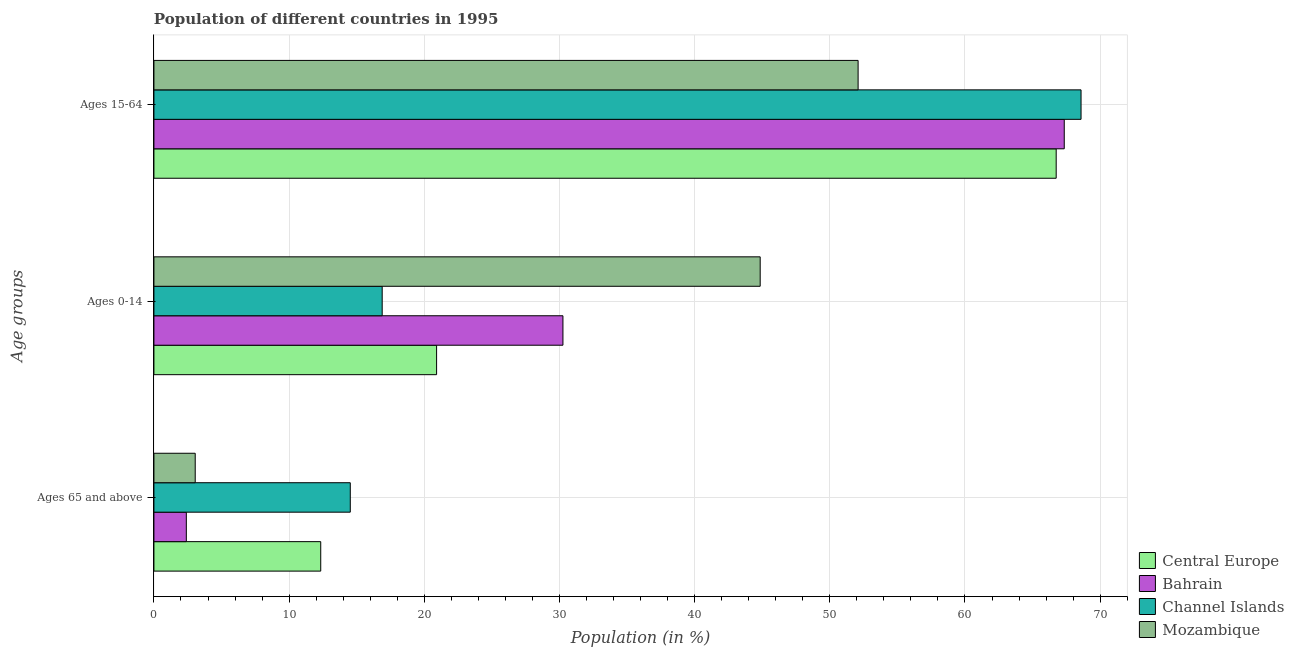How many different coloured bars are there?
Ensure brevity in your answer.  4. How many groups of bars are there?
Ensure brevity in your answer.  3. Are the number of bars per tick equal to the number of legend labels?
Your answer should be very brief. Yes. How many bars are there on the 2nd tick from the bottom?
Ensure brevity in your answer.  4. What is the label of the 1st group of bars from the top?
Give a very brief answer. Ages 15-64. What is the percentage of population within the age-group 0-14 in Channel Islands?
Your answer should be compact. 16.89. Across all countries, what is the maximum percentage of population within the age-group 0-14?
Ensure brevity in your answer.  44.85. Across all countries, what is the minimum percentage of population within the age-group 0-14?
Offer a very short reply. 16.89. In which country was the percentage of population within the age-group of 65 and above maximum?
Give a very brief answer. Channel Islands. In which country was the percentage of population within the age-group 15-64 minimum?
Your answer should be compact. Mozambique. What is the total percentage of population within the age-group 0-14 in the graph?
Make the answer very short. 112.91. What is the difference between the percentage of population within the age-group 15-64 in Channel Islands and that in Central Europe?
Offer a terse response. 1.84. What is the difference between the percentage of population within the age-group of 65 and above in Mozambique and the percentage of population within the age-group 0-14 in Bahrain?
Your answer should be compact. -27.2. What is the average percentage of population within the age-group 15-64 per country?
Keep it short and to the point. 63.69. What is the difference between the percentage of population within the age-group of 65 and above and percentage of population within the age-group 15-64 in Central Europe?
Your answer should be very brief. -54.41. What is the ratio of the percentage of population within the age-group of 65 and above in Mozambique to that in Channel Islands?
Offer a terse response. 0.21. Is the difference between the percentage of population within the age-group 0-14 in Central Europe and Mozambique greater than the difference between the percentage of population within the age-group 15-64 in Central Europe and Mozambique?
Your answer should be compact. No. What is the difference between the highest and the second highest percentage of population within the age-group of 65 and above?
Ensure brevity in your answer.  2.19. What is the difference between the highest and the lowest percentage of population within the age-group 15-64?
Keep it short and to the point. 16.49. What does the 2nd bar from the top in Ages 65 and above represents?
Your response must be concise. Channel Islands. What does the 3rd bar from the bottom in Ages 15-64 represents?
Offer a terse response. Channel Islands. How many bars are there?
Provide a succinct answer. 12. How many countries are there in the graph?
Offer a very short reply. 4. What is the difference between two consecutive major ticks on the X-axis?
Your answer should be very brief. 10. Does the graph contain any zero values?
Your answer should be compact. No. Does the graph contain grids?
Provide a succinct answer. Yes. Where does the legend appear in the graph?
Offer a terse response. Bottom right. What is the title of the graph?
Your answer should be very brief. Population of different countries in 1995. What is the label or title of the Y-axis?
Provide a short and direct response. Age groups. What is the Population (in %) of Central Europe in Ages 65 and above?
Offer a very short reply. 12.34. What is the Population (in %) in Bahrain in Ages 65 and above?
Keep it short and to the point. 2.4. What is the Population (in %) in Channel Islands in Ages 65 and above?
Keep it short and to the point. 14.53. What is the Population (in %) in Mozambique in Ages 65 and above?
Provide a succinct answer. 3.05. What is the Population (in %) of Central Europe in Ages 0-14?
Offer a terse response. 20.91. What is the Population (in %) of Bahrain in Ages 0-14?
Make the answer very short. 30.26. What is the Population (in %) in Channel Islands in Ages 0-14?
Give a very brief answer. 16.89. What is the Population (in %) in Mozambique in Ages 0-14?
Offer a terse response. 44.85. What is the Population (in %) of Central Europe in Ages 15-64?
Provide a short and direct response. 66.75. What is the Population (in %) in Bahrain in Ages 15-64?
Your answer should be compact. 67.35. What is the Population (in %) in Channel Islands in Ages 15-64?
Your response must be concise. 68.59. What is the Population (in %) in Mozambique in Ages 15-64?
Provide a short and direct response. 52.09. Across all Age groups, what is the maximum Population (in %) of Central Europe?
Ensure brevity in your answer.  66.75. Across all Age groups, what is the maximum Population (in %) in Bahrain?
Provide a short and direct response. 67.35. Across all Age groups, what is the maximum Population (in %) of Channel Islands?
Ensure brevity in your answer.  68.59. Across all Age groups, what is the maximum Population (in %) of Mozambique?
Your answer should be very brief. 52.09. Across all Age groups, what is the minimum Population (in %) of Central Europe?
Give a very brief answer. 12.34. Across all Age groups, what is the minimum Population (in %) of Bahrain?
Your response must be concise. 2.4. Across all Age groups, what is the minimum Population (in %) in Channel Islands?
Offer a very short reply. 14.53. Across all Age groups, what is the minimum Population (in %) of Mozambique?
Provide a succinct answer. 3.05. What is the total Population (in %) in Channel Islands in the graph?
Offer a very short reply. 100. What is the total Population (in %) of Mozambique in the graph?
Provide a short and direct response. 100. What is the difference between the Population (in %) of Central Europe in Ages 65 and above and that in Ages 0-14?
Your response must be concise. -8.57. What is the difference between the Population (in %) of Bahrain in Ages 65 and above and that in Ages 0-14?
Make the answer very short. -27.86. What is the difference between the Population (in %) of Channel Islands in Ages 65 and above and that in Ages 0-14?
Give a very brief answer. -2.36. What is the difference between the Population (in %) of Mozambique in Ages 65 and above and that in Ages 0-14?
Your answer should be compact. -41.8. What is the difference between the Population (in %) of Central Europe in Ages 65 and above and that in Ages 15-64?
Provide a succinct answer. -54.41. What is the difference between the Population (in %) of Bahrain in Ages 65 and above and that in Ages 15-64?
Give a very brief answer. -64.95. What is the difference between the Population (in %) in Channel Islands in Ages 65 and above and that in Ages 15-64?
Offer a terse response. -54.06. What is the difference between the Population (in %) in Mozambique in Ages 65 and above and that in Ages 15-64?
Make the answer very short. -49.04. What is the difference between the Population (in %) of Central Europe in Ages 0-14 and that in Ages 15-64?
Provide a succinct answer. -45.84. What is the difference between the Population (in %) in Bahrain in Ages 0-14 and that in Ages 15-64?
Make the answer very short. -37.09. What is the difference between the Population (in %) of Channel Islands in Ages 0-14 and that in Ages 15-64?
Provide a short and direct response. -51.7. What is the difference between the Population (in %) of Mozambique in Ages 0-14 and that in Ages 15-64?
Your answer should be very brief. -7.24. What is the difference between the Population (in %) in Central Europe in Ages 65 and above and the Population (in %) in Bahrain in Ages 0-14?
Ensure brevity in your answer.  -17.92. What is the difference between the Population (in %) of Central Europe in Ages 65 and above and the Population (in %) of Channel Islands in Ages 0-14?
Offer a terse response. -4.55. What is the difference between the Population (in %) in Central Europe in Ages 65 and above and the Population (in %) in Mozambique in Ages 0-14?
Your response must be concise. -32.51. What is the difference between the Population (in %) of Bahrain in Ages 65 and above and the Population (in %) of Channel Islands in Ages 0-14?
Offer a very short reply. -14.49. What is the difference between the Population (in %) in Bahrain in Ages 65 and above and the Population (in %) in Mozambique in Ages 0-14?
Provide a short and direct response. -42.45. What is the difference between the Population (in %) in Channel Islands in Ages 65 and above and the Population (in %) in Mozambique in Ages 0-14?
Make the answer very short. -30.32. What is the difference between the Population (in %) of Central Europe in Ages 65 and above and the Population (in %) of Bahrain in Ages 15-64?
Offer a terse response. -55. What is the difference between the Population (in %) of Central Europe in Ages 65 and above and the Population (in %) of Channel Islands in Ages 15-64?
Provide a succinct answer. -56.25. What is the difference between the Population (in %) in Central Europe in Ages 65 and above and the Population (in %) in Mozambique in Ages 15-64?
Make the answer very short. -39.75. What is the difference between the Population (in %) of Bahrain in Ages 65 and above and the Population (in %) of Channel Islands in Ages 15-64?
Offer a very short reply. -66.19. What is the difference between the Population (in %) in Bahrain in Ages 65 and above and the Population (in %) in Mozambique in Ages 15-64?
Make the answer very short. -49.7. What is the difference between the Population (in %) of Channel Islands in Ages 65 and above and the Population (in %) of Mozambique in Ages 15-64?
Make the answer very short. -37.57. What is the difference between the Population (in %) of Central Europe in Ages 0-14 and the Population (in %) of Bahrain in Ages 15-64?
Offer a very short reply. -46.43. What is the difference between the Population (in %) of Central Europe in Ages 0-14 and the Population (in %) of Channel Islands in Ages 15-64?
Offer a very short reply. -47.68. What is the difference between the Population (in %) in Central Europe in Ages 0-14 and the Population (in %) in Mozambique in Ages 15-64?
Offer a terse response. -31.18. What is the difference between the Population (in %) in Bahrain in Ages 0-14 and the Population (in %) in Channel Islands in Ages 15-64?
Keep it short and to the point. -38.33. What is the difference between the Population (in %) in Bahrain in Ages 0-14 and the Population (in %) in Mozambique in Ages 15-64?
Provide a short and direct response. -21.84. What is the difference between the Population (in %) of Channel Islands in Ages 0-14 and the Population (in %) of Mozambique in Ages 15-64?
Offer a very short reply. -35.21. What is the average Population (in %) of Central Europe per Age groups?
Ensure brevity in your answer.  33.33. What is the average Population (in %) in Bahrain per Age groups?
Offer a terse response. 33.33. What is the average Population (in %) of Channel Islands per Age groups?
Offer a very short reply. 33.33. What is the average Population (in %) of Mozambique per Age groups?
Your response must be concise. 33.33. What is the difference between the Population (in %) in Central Europe and Population (in %) in Bahrain in Ages 65 and above?
Your response must be concise. 9.94. What is the difference between the Population (in %) in Central Europe and Population (in %) in Channel Islands in Ages 65 and above?
Ensure brevity in your answer.  -2.19. What is the difference between the Population (in %) in Central Europe and Population (in %) in Mozambique in Ages 65 and above?
Keep it short and to the point. 9.29. What is the difference between the Population (in %) of Bahrain and Population (in %) of Channel Islands in Ages 65 and above?
Your response must be concise. -12.13. What is the difference between the Population (in %) of Bahrain and Population (in %) of Mozambique in Ages 65 and above?
Offer a very short reply. -0.66. What is the difference between the Population (in %) in Channel Islands and Population (in %) in Mozambique in Ages 65 and above?
Keep it short and to the point. 11.47. What is the difference between the Population (in %) of Central Europe and Population (in %) of Bahrain in Ages 0-14?
Provide a short and direct response. -9.35. What is the difference between the Population (in %) in Central Europe and Population (in %) in Channel Islands in Ages 0-14?
Provide a short and direct response. 4.02. What is the difference between the Population (in %) in Central Europe and Population (in %) in Mozambique in Ages 0-14?
Your response must be concise. -23.94. What is the difference between the Population (in %) in Bahrain and Population (in %) in Channel Islands in Ages 0-14?
Your answer should be very brief. 13.37. What is the difference between the Population (in %) of Bahrain and Population (in %) of Mozambique in Ages 0-14?
Make the answer very short. -14.59. What is the difference between the Population (in %) in Channel Islands and Population (in %) in Mozambique in Ages 0-14?
Give a very brief answer. -27.96. What is the difference between the Population (in %) of Central Europe and Population (in %) of Bahrain in Ages 15-64?
Keep it short and to the point. -0.6. What is the difference between the Population (in %) in Central Europe and Population (in %) in Channel Islands in Ages 15-64?
Offer a terse response. -1.84. What is the difference between the Population (in %) in Central Europe and Population (in %) in Mozambique in Ages 15-64?
Offer a terse response. 14.65. What is the difference between the Population (in %) of Bahrain and Population (in %) of Channel Islands in Ages 15-64?
Your response must be concise. -1.24. What is the difference between the Population (in %) of Bahrain and Population (in %) of Mozambique in Ages 15-64?
Ensure brevity in your answer.  15.25. What is the difference between the Population (in %) in Channel Islands and Population (in %) in Mozambique in Ages 15-64?
Make the answer very short. 16.49. What is the ratio of the Population (in %) in Central Europe in Ages 65 and above to that in Ages 0-14?
Give a very brief answer. 0.59. What is the ratio of the Population (in %) in Bahrain in Ages 65 and above to that in Ages 0-14?
Keep it short and to the point. 0.08. What is the ratio of the Population (in %) of Channel Islands in Ages 65 and above to that in Ages 0-14?
Your answer should be very brief. 0.86. What is the ratio of the Population (in %) in Mozambique in Ages 65 and above to that in Ages 0-14?
Your answer should be very brief. 0.07. What is the ratio of the Population (in %) in Central Europe in Ages 65 and above to that in Ages 15-64?
Ensure brevity in your answer.  0.18. What is the ratio of the Population (in %) of Bahrain in Ages 65 and above to that in Ages 15-64?
Provide a succinct answer. 0.04. What is the ratio of the Population (in %) of Channel Islands in Ages 65 and above to that in Ages 15-64?
Your answer should be compact. 0.21. What is the ratio of the Population (in %) in Mozambique in Ages 65 and above to that in Ages 15-64?
Keep it short and to the point. 0.06. What is the ratio of the Population (in %) of Central Europe in Ages 0-14 to that in Ages 15-64?
Keep it short and to the point. 0.31. What is the ratio of the Population (in %) of Bahrain in Ages 0-14 to that in Ages 15-64?
Your response must be concise. 0.45. What is the ratio of the Population (in %) of Channel Islands in Ages 0-14 to that in Ages 15-64?
Ensure brevity in your answer.  0.25. What is the ratio of the Population (in %) of Mozambique in Ages 0-14 to that in Ages 15-64?
Provide a succinct answer. 0.86. What is the difference between the highest and the second highest Population (in %) in Central Europe?
Keep it short and to the point. 45.84. What is the difference between the highest and the second highest Population (in %) of Bahrain?
Give a very brief answer. 37.09. What is the difference between the highest and the second highest Population (in %) in Channel Islands?
Give a very brief answer. 51.7. What is the difference between the highest and the second highest Population (in %) of Mozambique?
Offer a very short reply. 7.24. What is the difference between the highest and the lowest Population (in %) of Central Europe?
Keep it short and to the point. 54.41. What is the difference between the highest and the lowest Population (in %) of Bahrain?
Give a very brief answer. 64.95. What is the difference between the highest and the lowest Population (in %) in Channel Islands?
Your response must be concise. 54.06. What is the difference between the highest and the lowest Population (in %) in Mozambique?
Provide a succinct answer. 49.04. 